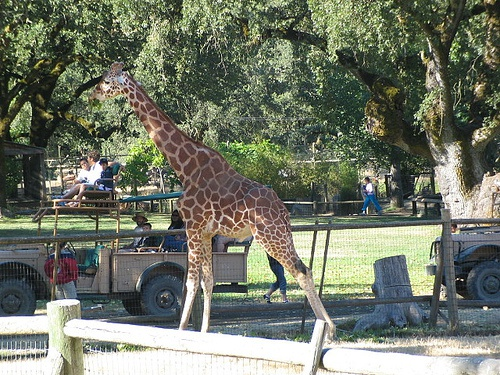Describe the objects in this image and their specific colors. I can see giraffe in black, gray, darkgray, and maroon tones, truck in black, gray, blue, and darkblue tones, people in black, gray, maroon, and purple tones, people in black, navy, gray, and blue tones, and people in black, gray, navy, and blue tones in this image. 